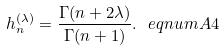<formula> <loc_0><loc_0><loc_500><loc_500>h _ { n } ^ { ( \lambda ) } = \frac { \Gamma ( n + 2 \lambda ) } { \Gamma ( n + 1 ) } . \ e q n u m { A 4 }</formula> 